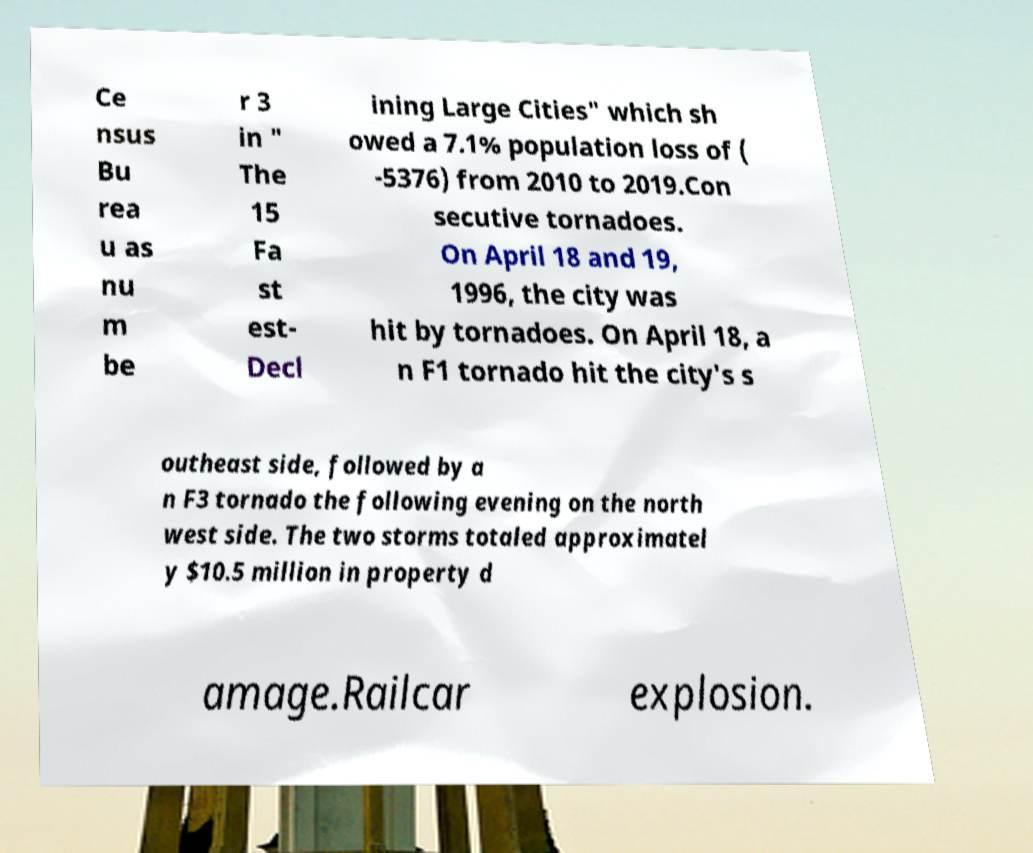Can you read and provide the text displayed in the image?This photo seems to have some interesting text. Can you extract and type it out for me? Ce nsus Bu rea u as nu m be r 3 in " The 15 Fa st est- Decl ining Large Cities" which sh owed a 7.1% population loss of ( -5376) from 2010 to 2019.Con secutive tornadoes. On April 18 and 19, 1996, the city was hit by tornadoes. On April 18, a n F1 tornado hit the city's s outheast side, followed by a n F3 tornado the following evening on the north west side. The two storms totaled approximatel y $10.5 million in property d amage.Railcar explosion. 